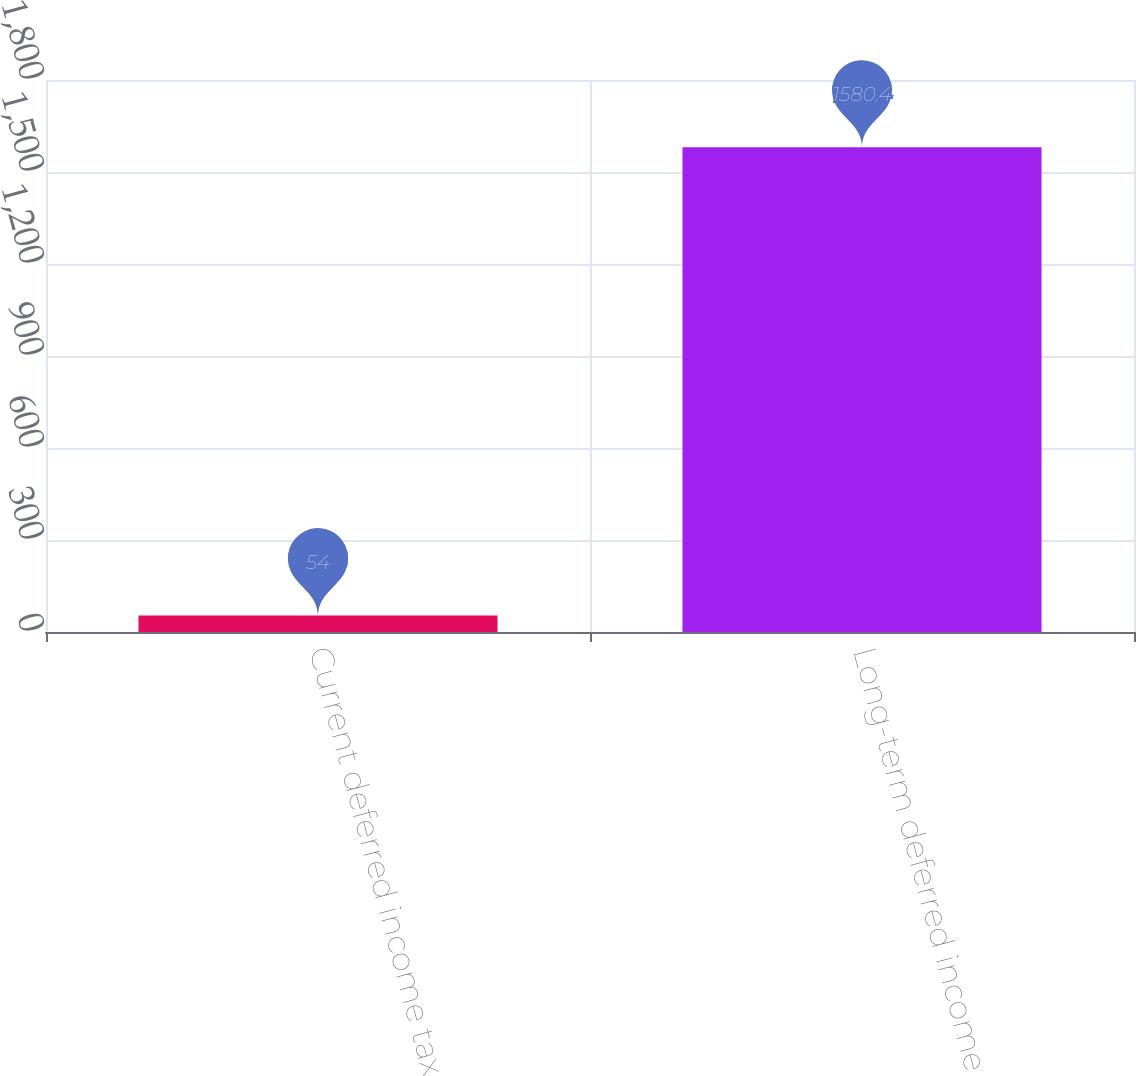<chart> <loc_0><loc_0><loc_500><loc_500><bar_chart><fcel>Current deferred income tax<fcel>Long-term deferred income tax<nl><fcel>54<fcel>1580.4<nl></chart> 